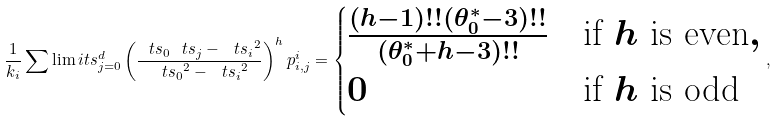<formula> <loc_0><loc_0><loc_500><loc_500>\frac { 1 } { k _ { i } } \sum \lim i t s _ { j = 0 } ^ { d } \left ( \frac { \ t s _ { 0 } \ t s _ { j } - { \ t s _ { i } } ^ { 2 } } { { \ t s _ { 0 } } ^ { 2 } - { \ t s _ { i } } ^ { 2 } } \right ) ^ { h } p _ { i , j } ^ { i } = \begin{cases} \frac { ( h - 1 ) ! ! ( \theta _ { 0 } ^ { * } - 3 ) ! ! } { ( \theta _ { 0 } ^ { * } + h - 3 ) ! ! } & \text {if} \ h \text { is even} , \\ 0 & \text {if} \ h \text { is odd} \end{cases} ,</formula> 